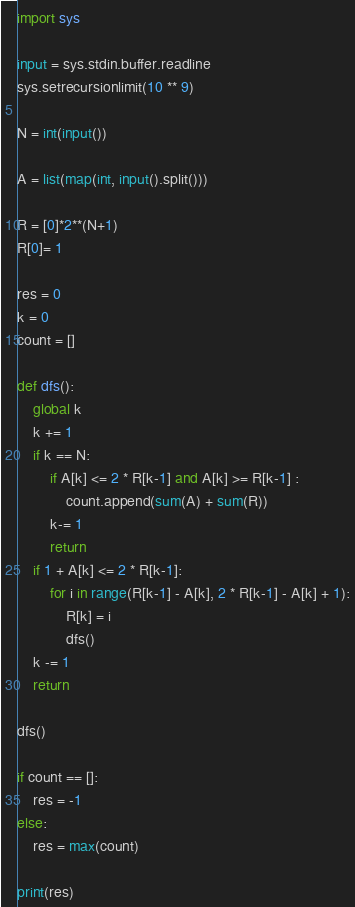<code> <loc_0><loc_0><loc_500><loc_500><_Python_>import sys

input = sys.stdin.buffer.readline
sys.setrecursionlimit(10 ** 9)

N = int(input())

A = list(map(int, input().split()))

R = [0]*2**(N+1)
R[0]= 1

res = 0
k = 0
count = []

def dfs():
    global k
    k += 1
    if k == N:
        if A[k] <= 2 * R[k-1] and A[k] >= R[k-1] :
            count.append(sum(A) + sum(R))
        k-= 1
        return
    if 1 + A[k] <= 2 * R[k-1]:
        for i in range(R[k-1] - A[k], 2 * R[k-1] - A[k] + 1):
            R[k] = i
            dfs()
    k -= 1
    return

dfs()

if count == []:
    res = -1
else:
    res = max(count)

print(res)

</code> 